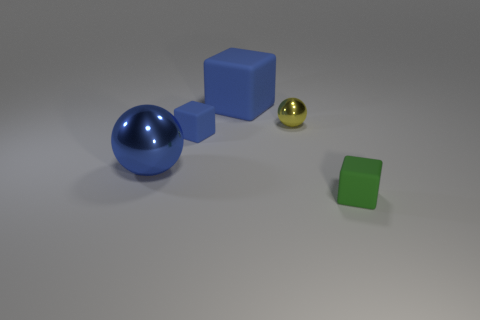What is the large blue object, and what material does it appear to be made of? The large blue object looks like a shiny sphere, potentially made of a material like polished metal or plastic due to its reflective surface and smooth texture. 